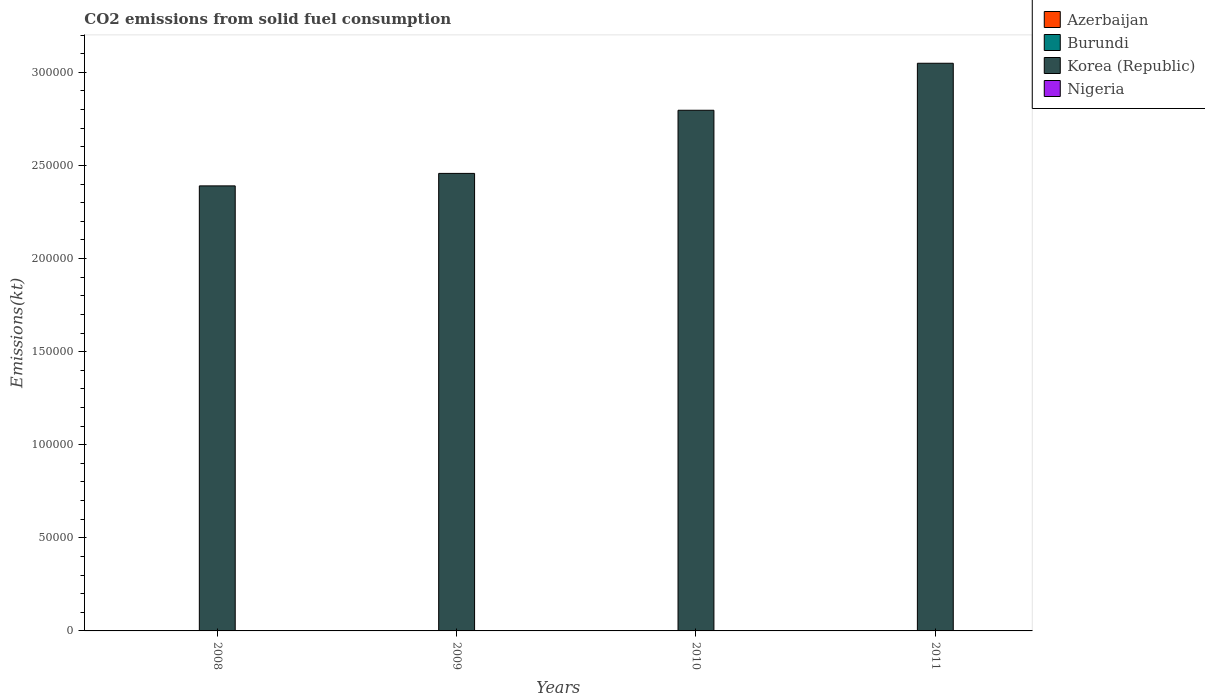How many different coloured bars are there?
Your answer should be very brief. 4. How many groups of bars are there?
Keep it short and to the point. 4. How many bars are there on the 1st tick from the left?
Your response must be concise. 4. What is the amount of CO2 emitted in Nigeria in 2008?
Provide a succinct answer. 91.67. Across all years, what is the maximum amount of CO2 emitted in Nigeria?
Your answer should be compact. 106.34. Across all years, what is the minimum amount of CO2 emitted in Burundi?
Your response must be concise. 11. What is the total amount of CO2 emitted in Nigeria in the graph?
Make the answer very short. 388.7. What is the difference between the amount of CO2 emitted in Korea (Republic) in 2008 and that in 2011?
Offer a terse response. -6.59e+04. What is the difference between the amount of CO2 emitted in Korea (Republic) in 2011 and the amount of CO2 emitted in Nigeria in 2009?
Your answer should be very brief. 3.05e+05. What is the average amount of CO2 emitted in Burundi per year?
Keep it short and to the point. 14.67. In the year 2011, what is the difference between the amount of CO2 emitted in Korea (Republic) and amount of CO2 emitted in Azerbaijan?
Keep it short and to the point. 3.05e+05. What is the ratio of the amount of CO2 emitted in Burundi in 2009 to that in 2011?
Provide a short and direct response. 1.33. Is the amount of CO2 emitted in Azerbaijan in 2010 less than that in 2011?
Offer a terse response. No. Is the difference between the amount of CO2 emitted in Korea (Republic) in 2009 and 2011 greater than the difference between the amount of CO2 emitted in Azerbaijan in 2009 and 2011?
Provide a short and direct response. No. What is the difference between the highest and the second highest amount of CO2 emitted in Nigeria?
Make the answer very short. 7.33. What is the difference between the highest and the lowest amount of CO2 emitted in Korea (Republic)?
Your response must be concise. 6.59e+04. In how many years, is the amount of CO2 emitted in Azerbaijan greater than the average amount of CO2 emitted in Azerbaijan taken over all years?
Offer a terse response. 2. Is the sum of the amount of CO2 emitted in Korea (Republic) in 2008 and 2009 greater than the maximum amount of CO2 emitted in Burundi across all years?
Your response must be concise. Yes. Is it the case that in every year, the sum of the amount of CO2 emitted in Nigeria and amount of CO2 emitted in Burundi is greater than the sum of amount of CO2 emitted in Korea (Republic) and amount of CO2 emitted in Azerbaijan?
Offer a very short reply. Yes. What does the 1st bar from the left in 2011 represents?
Give a very brief answer. Azerbaijan. What does the 3rd bar from the right in 2010 represents?
Ensure brevity in your answer.  Burundi. Is it the case that in every year, the sum of the amount of CO2 emitted in Korea (Republic) and amount of CO2 emitted in Burundi is greater than the amount of CO2 emitted in Nigeria?
Your answer should be very brief. Yes. What is the difference between two consecutive major ticks on the Y-axis?
Provide a short and direct response. 5.00e+04. Does the graph contain grids?
Provide a succinct answer. No. How are the legend labels stacked?
Provide a short and direct response. Vertical. What is the title of the graph?
Keep it short and to the point. CO2 emissions from solid fuel consumption. Does "Upper middle income" appear as one of the legend labels in the graph?
Offer a terse response. No. What is the label or title of the X-axis?
Offer a very short reply. Years. What is the label or title of the Y-axis?
Provide a short and direct response. Emissions(kt). What is the Emissions(kt) of Azerbaijan in 2008?
Provide a short and direct response. 14.67. What is the Emissions(kt) in Burundi in 2008?
Provide a succinct answer. 14.67. What is the Emissions(kt) of Korea (Republic) in 2008?
Your answer should be compact. 2.39e+05. What is the Emissions(kt) in Nigeria in 2008?
Make the answer very short. 91.67. What is the Emissions(kt) of Azerbaijan in 2009?
Ensure brevity in your answer.  14.67. What is the Emissions(kt) of Burundi in 2009?
Keep it short and to the point. 14.67. What is the Emissions(kt) in Korea (Republic) in 2009?
Your answer should be compact. 2.46e+05. What is the Emissions(kt) in Nigeria in 2009?
Ensure brevity in your answer.  99.01. What is the Emissions(kt) in Azerbaijan in 2010?
Your answer should be compact. 22. What is the Emissions(kt) of Burundi in 2010?
Keep it short and to the point. 18.34. What is the Emissions(kt) in Korea (Republic) in 2010?
Make the answer very short. 2.80e+05. What is the Emissions(kt) in Nigeria in 2010?
Provide a succinct answer. 106.34. What is the Emissions(kt) in Azerbaijan in 2011?
Provide a succinct answer. 22. What is the Emissions(kt) in Burundi in 2011?
Your response must be concise. 11. What is the Emissions(kt) in Korea (Republic) in 2011?
Provide a succinct answer. 3.05e+05. What is the Emissions(kt) in Nigeria in 2011?
Offer a terse response. 91.67. Across all years, what is the maximum Emissions(kt) of Azerbaijan?
Ensure brevity in your answer.  22. Across all years, what is the maximum Emissions(kt) in Burundi?
Provide a short and direct response. 18.34. Across all years, what is the maximum Emissions(kt) in Korea (Republic)?
Give a very brief answer. 3.05e+05. Across all years, what is the maximum Emissions(kt) of Nigeria?
Offer a very short reply. 106.34. Across all years, what is the minimum Emissions(kt) in Azerbaijan?
Your response must be concise. 14.67. Across all years, what is the minimum Emissions(kt) in Burundi?
Offer a very short reply. 11. Across all years, what is the minimum Emissions(kt) in Korea (Republic)?
Your response must be concise. 2.39e+05. Across all years, what is the minimum Emissions(kt) of Nigeria?
Your answer should be compact. 91.67. What is the total Emissions(kt) in Azerbaijan in the graph?
Offer a terse response. 73.34. What is the total Emissions(kt) of Burundi in the graph?
Offer a terse response. 58.67. What is the total Emissions(kt) of Korea (Republic) in the graph?
Provide a short and direct response. 1.07e+06. What is the total Emissions(kt) in Nigeria in the graph?
Give a very brief answer. 388.7. What is the difference between the Emissions(kt) of Burundi in 2008 and that in 2009?
Provide a short and direct response. 0. What is the difference between the Emissions(kt) in Korea (Republic) in 2008 and that in 2009?
Make the answer very short. -6703.28. What is the difference between the Emissions(kt) in Nigeria in 2008 and that in 2009?
Provide a short and direct response. -7.33. What is the difference between the Emissions(kt) of Azerbaijan in 2008 and that in 2010?
Your answer should be very brief. -7.33. What is the difference between the Emissions(kt) in Burundi in 2008 and that in 2010?
Keep it short and to the point. -3.67. What is the difference between the Emissions(kt) in Korea (Republic) in 2008 and that in 2010?
Your answer should be very brief. -4.06e+04. What is the difference between the Emissions(kt) in Nigeria in 2008 and that in 2010?
Your answer should be compact. -14.67. What is the difference between the Emissions(kt) in Azerbaijan in 2008 and that in 2011?
Your answer should be compact. -7.33. What is the difference between the Emissions(kt) of Burundi in 2008 and that in 2011?
Provide a short and direct response. 3.67. What is the difference between the Emissions(kt) in Korea (Republic) in 2008 and that in 2011?
Your response must be concise. -6.59e+04. What is the difference between the Emissions(kt) of Azerbaijan in 2009 and that in 2010?
Offer a terse response. -7.33. What is the difference between the Emissions(kt) in Burundi in 2009 and that in 2010?
Your response must be concise. -3.67. What is the difference between the Emissions(kt) of Korea (Republic) in 2009 and that in 2010?
Keep it short and to the point. -3.39e+04. What is the difference between the Emissions(kt) of Nigeria in 2009 and that in 2010?
Keep it short and to the point. -7.33. What is the difference between the Emissions(kt) of Azerbaijan in 2009 and that in 2011?
Ensure brevity in your answer.  -7.33. What is the difference between the Emissions(kt) of Burundi in 2009 and that in 2011?
Offer a terse response. 3.67. What is the difference between the Emissions(kt) in Korea (Republic) in 2009 and that in 2011?
Ensure brevity in your answer.  -5.92e+04. What is the difference between the Emissions(kt) in Nigeria in 2009 and that in 2011?
Provide a short and direct response. 7.33. What is the difference between the Emissions(kt) of Azerbaijan in 2010 and that in 2011?
Offer a very short reply. 0. What is the difference between the Emissions(kt) of Burundi in 2010 and that in 2011?
Keep it short and to the point. 7.33. What is the difference between the Emissions(kt) of Korea (Republic) in 2010 and that in 2011?
Offer a terse response. -2.52e+04. What is the difference between the Emissions(kt) in Nigeria in 2010 and that in 2011?
Your answer should be compact. 14.67. What is the difference between the Emissions(kt) in Azerbaijan in 2008 and the Emissions(kt) in Burundi in 2009?
Your response must be concise. 0. What is the difference between the Emissions(kt) in Azerbaijan in 2008 and the Emissions(kt) in Korea (Republic) in 2009?
Offer a very short reply. -2.46e+05. What is the difference between the Emissions(kt) of Azerbaijan in 2008 and the Emissions(kt) of Nigeria in 2009?
Make the answer very short. -84.34. What is the difference between the Emissions(kt) in Burundi in 2008 and the Emissions(kt) in Korea (Republic) in 2009?
Ensure brevity in your answer.  -2.46e+05. What is the difference between the Emissions(kt) of Burundi in 2008 and the Emissions(kt) of Nigeria in 2009?
Make the answer very short. -84.34. What is the difference between the Emissions(kt) in Korea (Republic) in 2008 and the Emissions(kt) in Nigeria in 2009?
Your answer should be very brief. 2.39e+05. What is the difference between the Emissions(kt) of Azerbaijan in 2008 and the Emissions(kt) of Burundi in 2010?
Give a very brief answer. -3.67. What is the difference between the Emissions(kt) in Azerbaijan in 2008 and the Emissions(kt) in Korea (Republic) in 2010?
Provide a short and direct response. -2.80e+05. What is the difference between the Emissions(kt) in Azerbaijan in 2008 and the Emissions(kt) in Nigeria in 2010?
Ensure brevity in your answer.  -91.67. What is the difference between the Emissions(kt) in Burundi in 2008 and the Emissions(kt) in Korea (Republic) in 2010?
Provide a short and direct response. -2.80e+05. What is the difference between the Emissions(kt) in Burundi in 2008 and the Emissions(kt) in Nigeria in 2010?
Give a very brief answer. -91.67. What is the difference between the Emissions(kt) of Korea (Republic) in 2008 and the Emissions(kt) of Nigeria in 2010?
Ensure brevity in your answer.  2.39e+05. What is the difference between the Emissions(kt) of Azerbaijan in 2008 and the Emissions(kt) of Burundi in 2011?
Your response must be concise. 3.67. What is the difference between the Emissions(kt) of Azerbaijan in 2008 and the Emissions(kt) of Korea (Republic) in 2011?
Your answer should be very brief. -3.05e+05. What is the difference between the Emissions(kt) of Azerbaijan in 2008 and the Emissions(kt) of Nigeria in 2011?
Provide a succinct answer. -77.01. What is the difference between the Emissions(kt) in Burundi in 2008 and the Emissions(kt) in Korea (Republic) in 2011?
Ensure brevity in your answer.  -3.05e+05. What is the difference between the Emissions(kt) in Burundi in 2008 and the Emissions(kt) in Nigeria in 2011?
Offer a terse response. -77.01. What is the difference between the Emissions(kt) in Korea (Republic) in 2008 and the Emissions(kt) in Nigeria in 2011?
Your response must be concise. 2.39e+05. What is the difference between the Emissions(kt) in Azerbaijan in 2009 and the Emissions(kt) in Burundi in 2010?
Provide a short and direct response. -3.67. What is the difference between the Emissions(kt) in Azerbaijan in 2009 and the Emissions(kt) in Korea (Republic) in 2010?
Your response must be concise. -2.80e+05. What is the difference between the Emissions(kt) in Azerbaijan in 2009 and the Emissions(kt) in Nigeria in 2010?
Offer a very short reply. -91.67. What is the difference between the Emissions(kt) in Burundi in 2009 and the Emissions(kt) in Korea (Republic) in 2010?
Make the answer very short. -2.80e+05. What is the difference between the Emissions(kt) in Burundi in 2009 and the Emissions(kt) in Nigeria in 2010?
Make the answer very short. -91.67. What is the difference between the Emissions(kt) in Korea (Republic) in 2009 and the Emissions(kt) in Nigeria in 2010?
Provide a short and direct response. 2.46e+05. What is the difference between the Emissions(kt) in Azerbaijan in 2009 and the Emissions(kt) in Burundi in 2011?
Keep it short and to the point. 3.67. What is the difference between the Emissions(kt) of Azerbaijan in 2009 and the Emissions(kt) of Korea (Republic) in 2011?
Provide a short and direct response. -3.05e+05. What is the difference between the Emissions(kt) in Azerbaijan in 2009 and the Emissions(kt) in Nigeria in 2011?
Your answer should be very brief. -77.01. What is the difference between the Emissions(kt) of Burundi in 2009 and the Emissions(kt) of Korea (Republic) in 2011?
Provide a short and direct response. -3.05e+05. What is the difference between the Emissions(kt) of Burundi in 2009 and the Emissions(kt) of Nigeria in 2011?
Give a very brief answer. -77.01. What is the difference between the Emissions(kt) of Korea (Republic) in 2009 and the Emissions(kt) of Nigeria in 2011?
Offer a terse response. 2.46e+05. What is the difference between the Emissions(kt) in Azerbaijan in 2010 and the Emissions(kt) in Burundi in 2011?
Your response must be concise. 11. What is the difference between the Emissions(kt) in Azerbaijan in 2010 and the Emissions(kt) in Korea (Republic) in 2011?
Your answer should be compact. -3.05e+05. What is the difference between the Emissions(kt) in Azerbaijan in 2010 and the Emissions(kt) in Nigeria in 2011?
Ensure brevity in your answer.  -69.67. What is the difference between the Emissions(kt) in Burundi in 2010 and the Emissions(kt) in Korea (Republic) in 2011?
Ensure brevity in your answer.  -3.05e+05. What is the difference between the Emissions(kt) of Burundi in 2010 and the Emissions(kt) of Nigeria in 2011?
Give a very brief answer. -73.34. What is the difference between the Emissions(kt) in Korea (Republic) in 2010 and the Emissions(kt) in Nigeria in 2011?
Make the answer very short. 2.80e+05. What is the average Emissions(kt) in Azerbaijan per year?
Make the answer very short. 18.34. What is the average Emissions(kt) in Burundi per year?
Offer a very short reply. 14.67. What is the average Emissions(kt) of Korea (Republic) per year?
Ensure brevity in your answer.  2.67e+05. What is the average Emissions(kt) in Nigeria per year?
Your answer should be compact. 97.18. In the year 2008, what is the difference between the Emissions(kt) in Azerbaijan and Emissions(kt) in Korea (Republic)?
Ensure brevity in your answer.  -2.39e+05. In the year 2008, what is the difference between the Emissions(kt) in Azerbaijan and Emissions(kt) in Nigeria?
Your response must be concise. -77.01. In the year 2008, what is the difference between the Emissions(kt) in Burundi and Emissions(kt) in Korea (Republic)?
Keep it short and to the point. -2.39e+05. In the year 2008, what is the difference between the Emissions(kt) of Burundi and Emissions(kt) of Nigeria?
Ensure brevity in your answer.  -77.01. In the year 2008, what is the difference between the Emissions(kt) in Korea (Republic) and Emissions(kt) in Nigeria?
Provide a succinct answer. 2.39e+05. In the year 2009, what is the difference between the Emissions(kt) in Azerbaijan and Emissions(kt) in Burundi?
Make the answer very short. 0. In the year 2009, what is the difference between the Emissions(kt) in Azerbaijan and Emissions(kt) in Korea (Republic)?
Make the answer very short. -2.46e+05. In the year 2009, what is the difference between the Emissions(kt) in Azerbaijan and Emissions(kt) in Nigeria?
Your response must be concise. -84.34. In the year 2009, what is the difference between the Emissions(kt) of Burundi and Emissions(kt) of Korea (Republic)?
Make the answer very short. -2.46e+05. In the year 2009, what is the difference between the Emissions(kt) in Burundi and Emissions(kt) in Nigeria?
Ensure brevity in your answer.  -84.34. In the year 2009, what is the difference between the Emissions(kt) of Korea (Republic) and Emissions(kt) of Nigeria?
Ensure brevity in your answer.  2.46e+05. In the year 2010, what is the difference between the Emissions(kt) of Azerbaijan and Emissions(kt) of Burundi?
Make the answer very short. 3.67. In the year 2010, what is the difference between the Emissions(kt) of Azerbaijan and Emissions(kt) of Korea (Republic)?
Give a very brief answer. -2.80e+05. In the year 2010, what is the difference between the Emissions(kt) in Azerbaijan and Emissions(kt) in Nigeria?
Provide a short and direct response. -84.34. In the year 2010, what is the difference between the Emissions(kt) in Burundi and Emissions(kt) in Korea (Republic)?
Your answer should be very brief. -2.80e+05. In the year 2010, what is the difference between the Emissions(kt) in Burundi and Emissions(kt) in Nigeria?
Give a very brief answer. -88.01. In the year 2010, what is the difference between the Emissions(kt) of Korea (Republic) and Emissions(kt) of Nigeria?
Provide a short and direct response. 2.80e+05. In the year 2011, what is the difference between the Emissions(kt) of Azerbaijan and Emissions(kt) of Burundi?
Provide a short and direct response. 11. In the year 2011, what is the difference between the Emissions(kt) in Azerbaijan and Emissions(kt) in Korea (Republic)?
Your answer should be compact. -3.05e+05. In the year 2011, what is the difference between the Emissions(kt) in Azerbaijan and Emissions(kt) in Nigeria?
Keep it short and to the point. -69.67. In the year 2011, what is the difference between the Emissions(kt) in Burundi and Emissions(kt) in Korea (Republic)?
Your response must be concise. -3.05e+05. In the year 2011, what is the difference between the Emissions(kt) in Burundi and Emissions(kt) in Nigeria?
Make the answer very short. -80.67. In the year 2011, what is the difference between the Emissions(kt) of Korea (Republic) and Emissions(kt) of Nigeria?
Offer a terse response. 3.05e+05. What is the ratio of the Emissions(kt) in Korea (Republic) in 2008 to that in 2009?
Ensure brevity in your answer.  0.97. What is the ratio of the Emissions(kt) in Nigeria in 2008 to that in 2009?
Your response must be concise. 0.93. What is the ratio of the Emissions(kt) of Azerbaijan in 2008 to that in 2010?
Offer a very short reply. 0.67. What is the ratio of the Emissions(kt) of Korea (Republic) in 2008 to that in 2010?
Your answer should be compact. 0.85. What is the ratio of the Emissions(kt) in Nigeria in 2008 to that in 2010?
Ensure brevity in your answer.  0.86. What is the ratio of the Emissions(kt) of Burundi in 2008 to that in 2011?
Make the answer very short. 1.33. What is the ratio of the Emissions(kt) of Korea (Republic) in 2008 to that in 2011?
Provide a succinct answer. 0.78. What is the ratio of the Emissions(kt) in Nigeria in 2008 to that in 2011?
Provide a succinct answer. 1. What is the ratio of the Emissions(kt) of Azerbaijan in 2009 to that in 2010?
Your answer should be compact. 0.67. What is the ratio of the Emissions(kt) of Burundi in 2009 to that in 2010?
Provide a succinct answer. 0.8. What is the ratio of the Emissions(kt) in Korea (Republic) in 2009 to that in 2010?
Make the answer very short. 0.88. What is the ratio of the Emissions(kt) in Nigeria in 2009 to that in 2010?
Ensure brevity in your answer.  0.93. What is the ratio of the Emissions(kt) in Azerbaijan in 2009 to that in 2011?
Your response must be concise. 0.67. What is the ratio of the Emissions(kt) in Burundi in 2009 to that in 2011?
Make the answer very short. 1.33. What is the ratio of the Emissions(kt) in Korea (Republic) in 2009 to that in 2011?
Provide a short and direct response. 0.81. What is the ratio of the Emissions(kt) of Burundi in 2010 to that in 2011?
Your answer should be compact. 1.67. What is the ratio of the Emissions(kt) in Korea (Republic) in 2010 to that in 2011?
Your answer should be very brief. 0.92. What is the ratio of the Emissions(kt) of Nigeria in 2010 to that in 2011?
Give a very brief answer. 1.16. What is the difference between the highest and the second highest Emissions(kt) of Burundi?
Your answer should be very brief. 3.67. What is the difference between the highest and the second highest Emissions(kt) of Korea (Republic)?
Ensure brevity in your answer.  2.52e+04. What is the difference between the highest and the second highest Emissions(kt) of Nigeria?
Make the answer very short. 7.33. What is the difference between the highest and the lowest Emissions(kt) in Azerbaijan?
Offer a very short reply. 7.33. What is the difference between the highest and the lowest Emissions(kt) of Burundi?
Provide a succinct answer. 7.33. What is the difference between the highest and the lowest Emissions(kt) of Korea (Republic)?
Make the answer very short. 6.59e+04. What is the difference between the highest and the lowest Emissions(kt) in Nigeria?
Ensure brevity in your answer.  14.67. 